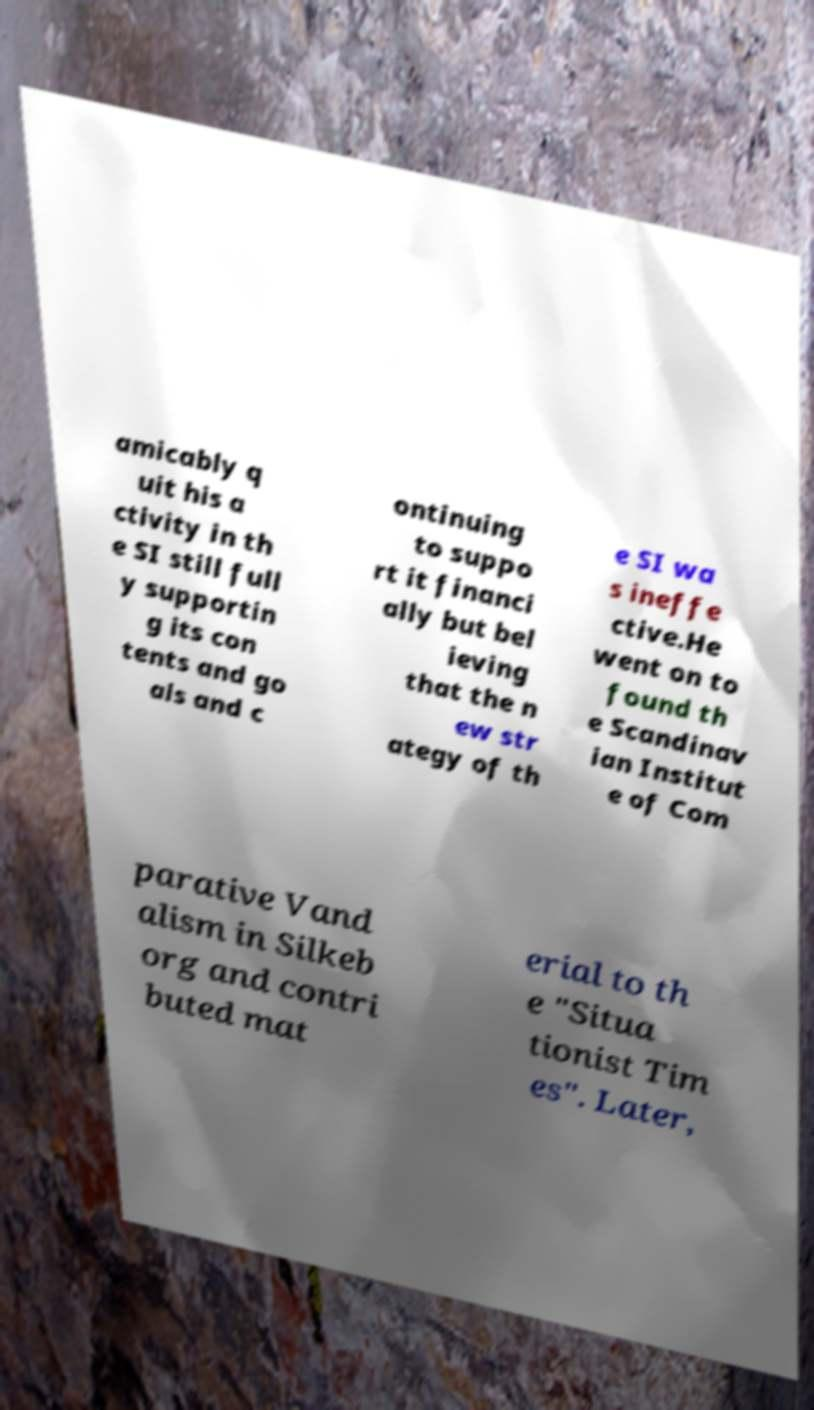Could you assist in decoding the text presented in this image and type it out clearly? amicably q uit his a ctivity in th e SI still full y supportin g its con tents and go als and c ontinuing to suppo rt it financi ally but bel ieving that the n ew str ategy of th e SI wa s ineffe ctive.He went on to found th e Scandinav ian Institut e of Com parative Vand alism in Silkeb org and contri buted mat erial to th e "Situa tionist Tim es". Later, 